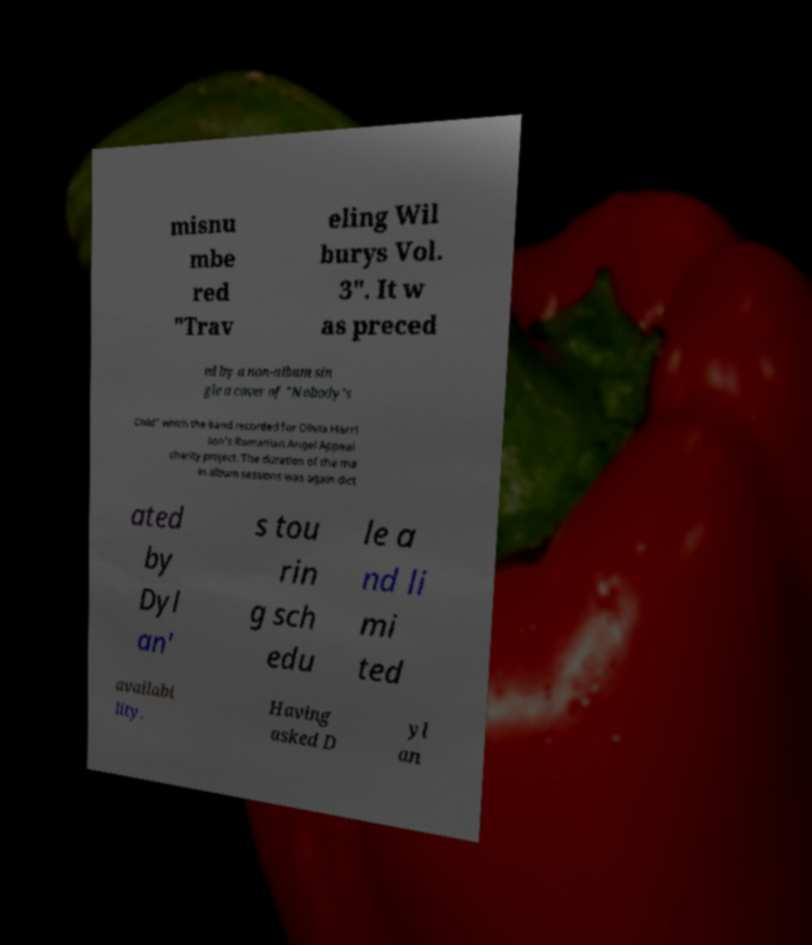Please read and relay the text visible in this image. What does it say? misnu mbe red "Trav eling Wil burys Vol. 3". It w as preced ed by a non-album sin gle a cover of "Nobody's Child" which the band recorded for Olivia Harri son's Romanian Angel Appeal charity project. The duration of the ma in album sessions was again dict ated by Dyl an' s tou rin g sch edu le a nd li mi ted availabi lity. Having asked D yl an 